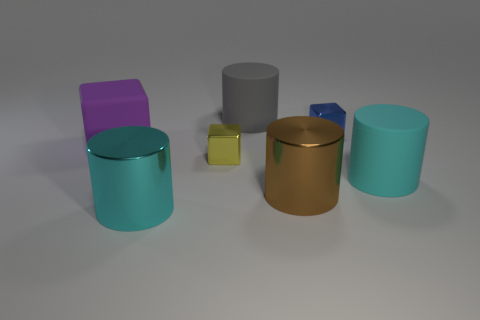Is the number of big brown metal cylinders less than the number of tiny blue shiny spheres?
Your response must be concise. No. Is the large cyan thing that is left of the yellow cube made of the same material as the yellow block?
Give a very brief answer. Yes. What number of balls are either purple matte things or big matte objects?
Ensure brevity in your answer.  0. The rubber thing that is in front of the gray object and on the left side of the brown shiny cylinder has what shape?
Your answer should be compact. Cube. What is the color of the metallic cylinder that is to the right of the cyan object in front of the big cyan cylinder that is on the right side of the blue metal block?
Make the answer very short. Brown. Are there fewer large gray objects that are in front of the big brown cylinder than tiny brown cylinders?
Ensure brevity in your answer.  No. There is a shiny thing that is left of the yellow metal cube; is its shape the same as the small shiny object that is on the right side of the brown object?
Ensure brevity in your answer.  No. What number of things are cyan matte cylinders behind the big brown object or yellow shiny blocks?
Give a very brief answer. 2. There is a shiny cylinder that is on the right side of the big cyan cylinder that is to the left of the cyan matte cylinder; is there a large purple object in front of it?
Offer a very short reply. No. Is the number of large cyan matte cylinders to the left of the purple matte cube less than the number of large cyan objects right of the cyan rubber cylinder?
Offer a very short reply. No. 